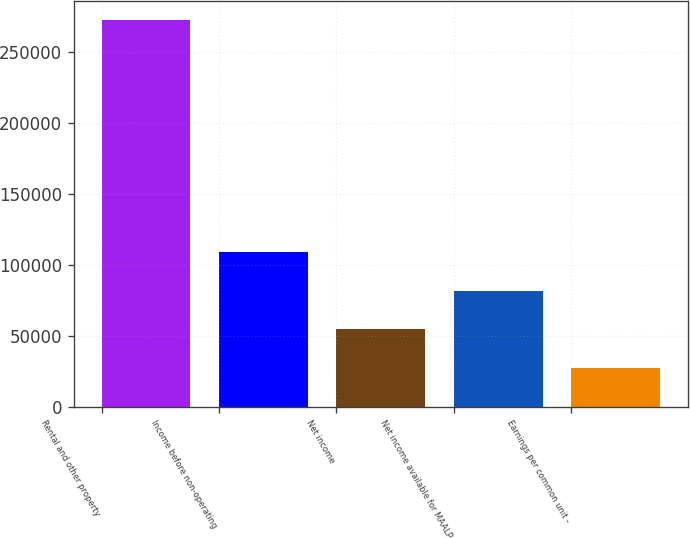<chart> <loc_0><loc_0><loc_500><loc_500><bar_chart><fcel>Rental and other property<fcel>Income before non-operating<fcel>Net income<fcel>Net income available for MAALP<fcel>Earnings per common unit -<nl><fcel>272236<fcel>108895<fcel>54447.7<fcel>81671.2<fcel>27224.1<nl></chart> 